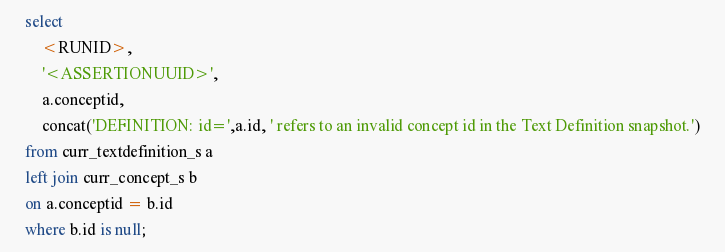Convert code to text. <code><loc_0><loc_0><loc_500><loc_500><_SQL_>	select 
		<RUNID>,
		'<ASSERTIONUUID>',
		a.conceptid,
		concat('DEFINITION: id=',a.id, ' refers to an invalid concept id in the Text Definition snapshot.') 	
	from curr_textdefinition_s a
	left join curr_concept_s b
	on a.conceptid = b.id
	where b.id is null;</code> 